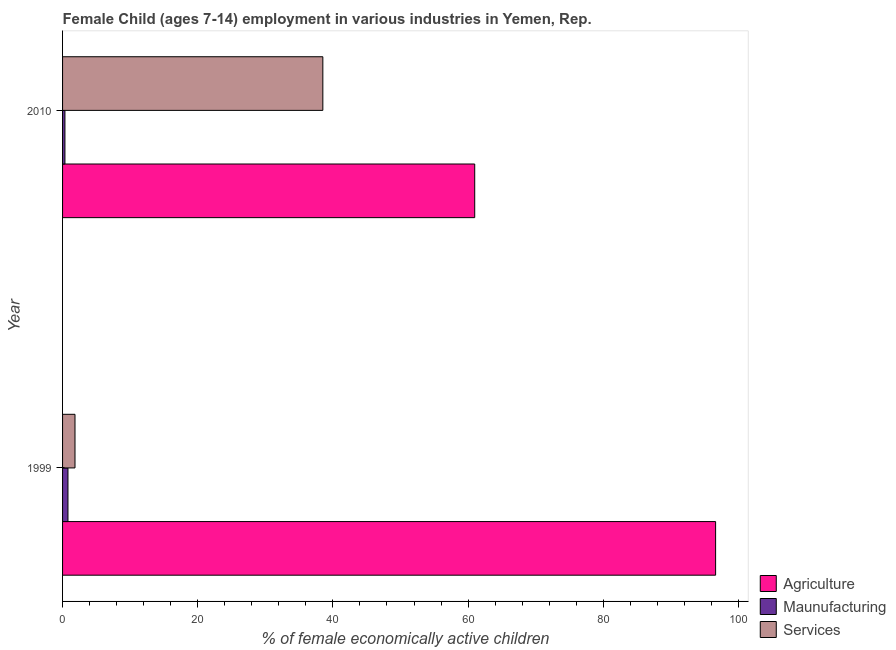How many different coloured bars are there?
Offer a very short reply. 3. How many groups of bars are there?
Keep it short and to the point. 2. How many bars are there on the 2nd tick from the bottom?
Provide a succinct answer. 3. In how many cases, is the number of bars for a given year not equal to the number of legend labels?
Your answer should be very brief. 0. Across all years, what is the maximum percentage of economically active children in agriculture?
Provide a short and direct response. 96.62. Across all years, what is the minimum percentage of economically active children in services?
Make the answer very short. 1.84. In which year was the percentage of economically active children in manufacturing minimum?
Give a very brief answer. 2010. What is the total percentage of economically active children in services in the graph?
Ensure brevity in your answer.  40.35. What is the difference between the percentage of economically active children in manufacturing in 1999 and that in 2010?
Make the answer very short. 0.45. What is the difference between the percentage of economically active children in services in 2010 and the percentage of economically active children in manufacturing in 1999?
Make the answer very short. 37.71. What is the average percentage of economically active children in manufacturing per year?
Ensure brevity in your answer.  0.57. In the year 2010, what is the difference between the percentage of economically active children in agriculture and percentage of economically active children in services?
Your answer should be compact. 22.47. What is the ratio of the percentage of economically active children in manufacturing in 1999 to that in 2010?
Your response must be concise. 2.29. What does the 3rd bar from the top in 2010 represents?
Keep it short and to the point. Agriculture. What does the 1st bar from the bottom in 2010 represents?
Your answer should be compact. Agriculture. Is it the case that in every year, the sum of the percentage of economically active children in agriculture and percentage of economically active children in manufacturing is greater than the percentage of economically active children in services?
Offer a terse response. Yes. How many years are there in the graph?
Your answer should be very brief. 2. What is the difference between two consecutive major ticks on the X-axis?
Keep it short and to the point. 20. How many legend labels are there?
Offer a very short reply. 3. How are the legend labels stacked?
Offer a terse response. Vertical. What is the title of the graph?
Make the answer very short. Female Child (ages 7-14) employment in various industries in Yemen, Rep. What is the label or title of the X-axis?
Offer a terse response. % of female economically active children. What is the % of female economically active children of Agriculture in 1999?
Offer a very short reply. 96.62. What is the % of female economically active children of Maunufacturing in 1999?
Make the answer very short. 0.8. What is the % of female economically active children of Services in 1999?
Your answer should be very brief. 1.84. What is the % of female economically active children of Agriculture in 2010?
Provide a short and direct response. 60.98. What is the % of female economically active children of Services in 2010?
Offer a terse response. 38.51. Across all years, what is the maximum % of female economically active children in Agriculture?
Offer a very short reply. 96.62. Across all years, what is the maximum % of female economically active children in Services?
Your answer should be compact. 38.51. Across all years, what is the minimum % of female economically active children in Agriculture?
Give a very brief answer. 60.98. Across all years, what is the minimum % of female economically active children in Services?
Your answer should be compact. 1.84. What is the total % of female economically active children of Agriculture in the graph?
Ensure brevity in your answer.  157.6. What is the total % of female economically active children of Maunufacturing in the graph?
Give a very brief answer. 1.15. What is the total % of female economically active children of Services in the graph?
Your answer should be very brief. 40.35. What is the difference between the % of female economically active children in Agriculture in 1999 and that in 2010?
Provide a short and direct response. 35.64. What is the difference between the % of female economically active children of Maunufacturing in 1999 and that in 2010?
Keep it short and to the point. 0.45. What is the difference between the % of female economically active children in Services in 1999 and that in 2010?
Your answer should be compact. -36.67. What is the difference between the % of female economically active children in Agriculture in 1999 and the % of female economically active children in Maunufacturing in 2010?
Your answer should be very brief. 96.27. What is the difference between the % of female economically active children in Agriculture in 1999 and the % of female economically active children in Services in 2010?
Offer a terse response. 58.11. What is the difference between the % of female economically active children of Maunufacturing in 1999 and the % of female economically active children of Services in 2010?
Offer a terse response. -37.71. What is the average % of female economically active children in Agriculture per year?
Your response must be concise. 78.8. What is the average % of female economically active children in Maunufacturing per year?
Ensure brevity in your answer.  0.57. What is the average % of female economically active children of Services per year?
Give a very brief answer. 20.18. In the year 1999, what is the difference between the % of female economically active children in Agriculture and % of female economically active children in Maunufacturing?
Give a very brief answer. 95.82. In the year 1999, what is the difference between the % of female economically active children of Agriculture and % of female economically active children of Services?
Your response must be concise. 94.78. In the year 1999, what is the difference between the % of female economically active children in Maunufacturing and % of female economically active children in Services?
Your answer should be very brief. -1.04. In the year 2010, what is the difference between the % of female economically active children of Agriculture and % of female economically active children of Maunufacturing?
Your answer should be very brief. 60.63. In the year 2010, what is the difference between the % of female economically active children of Agriculture and % of female economically active children of Services?
Your answer should be very brief. 22.47. In the year 2010, what is the difference between the % of female economically active children of Maunufacturing and % of female economically active children of Services?
Make the answer very short. -38.16. What is the ratio of the % of female economically active children in Agriculture in 1999 to that in 2010?
Ensure brevity in your answer.  1.58. What is the ratio of the % of female economically active children of Maunufacturing in 1999 to that in 2010?
Provide a short and direct response. 2.29. What is the ratio of the % of female economically active children of Services in 1999 to that in 2010?
Your answer should be compact. 0.05. What is the difference between the highest and the second highest % of female economically active children in Agriculture?
Ensure brevity in your answer.  35.64. What is the difference between the highest and the second highest % of female economically active children in Maunufacturing?
Keep it short and to the point. 0.45. What is the difference between the highest and the second highest % of female economically active children in Services?
Offer a terse response. 36.67. What is the difference between the highest and the lowest % of female economically active children in Agriculture?
Offer a very short reply. 35.64. What is the difference between the highest and the lowest % of female economically active children in Maunufacturing?
Provide a succinct answer. 0.45. What is the difference between the highest and the lowest % of female economically active children in Services?
Your response must be concise. 36.67. 